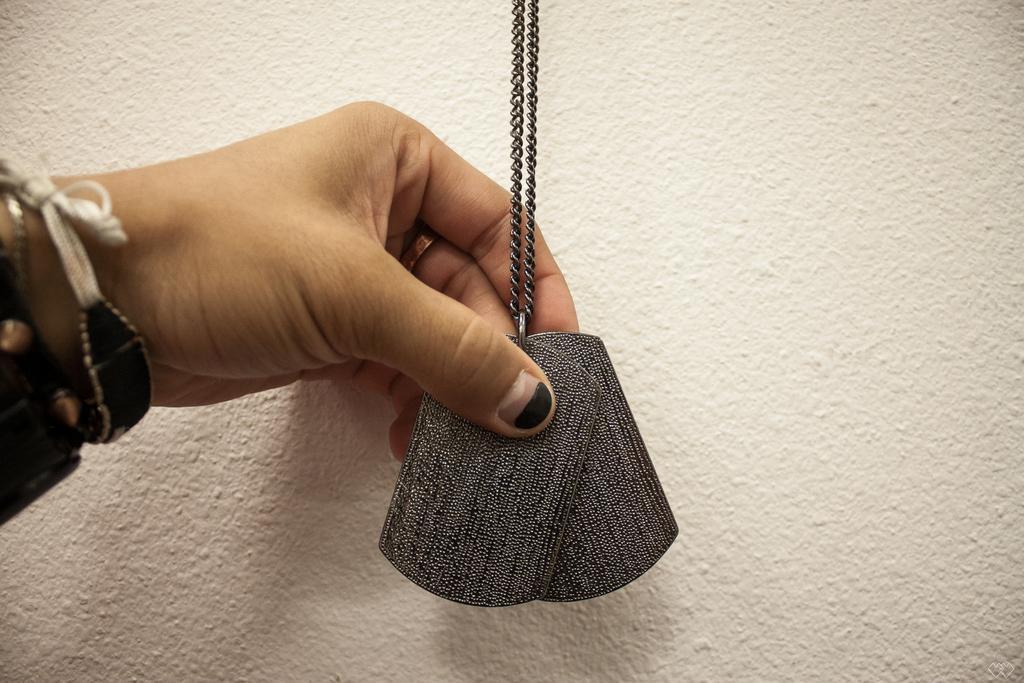How would you summarize this image in a sentence or two? In this picture, we see a hand of a person is holding a chain and locket. In the background, it is white in color. This might be a wall. 